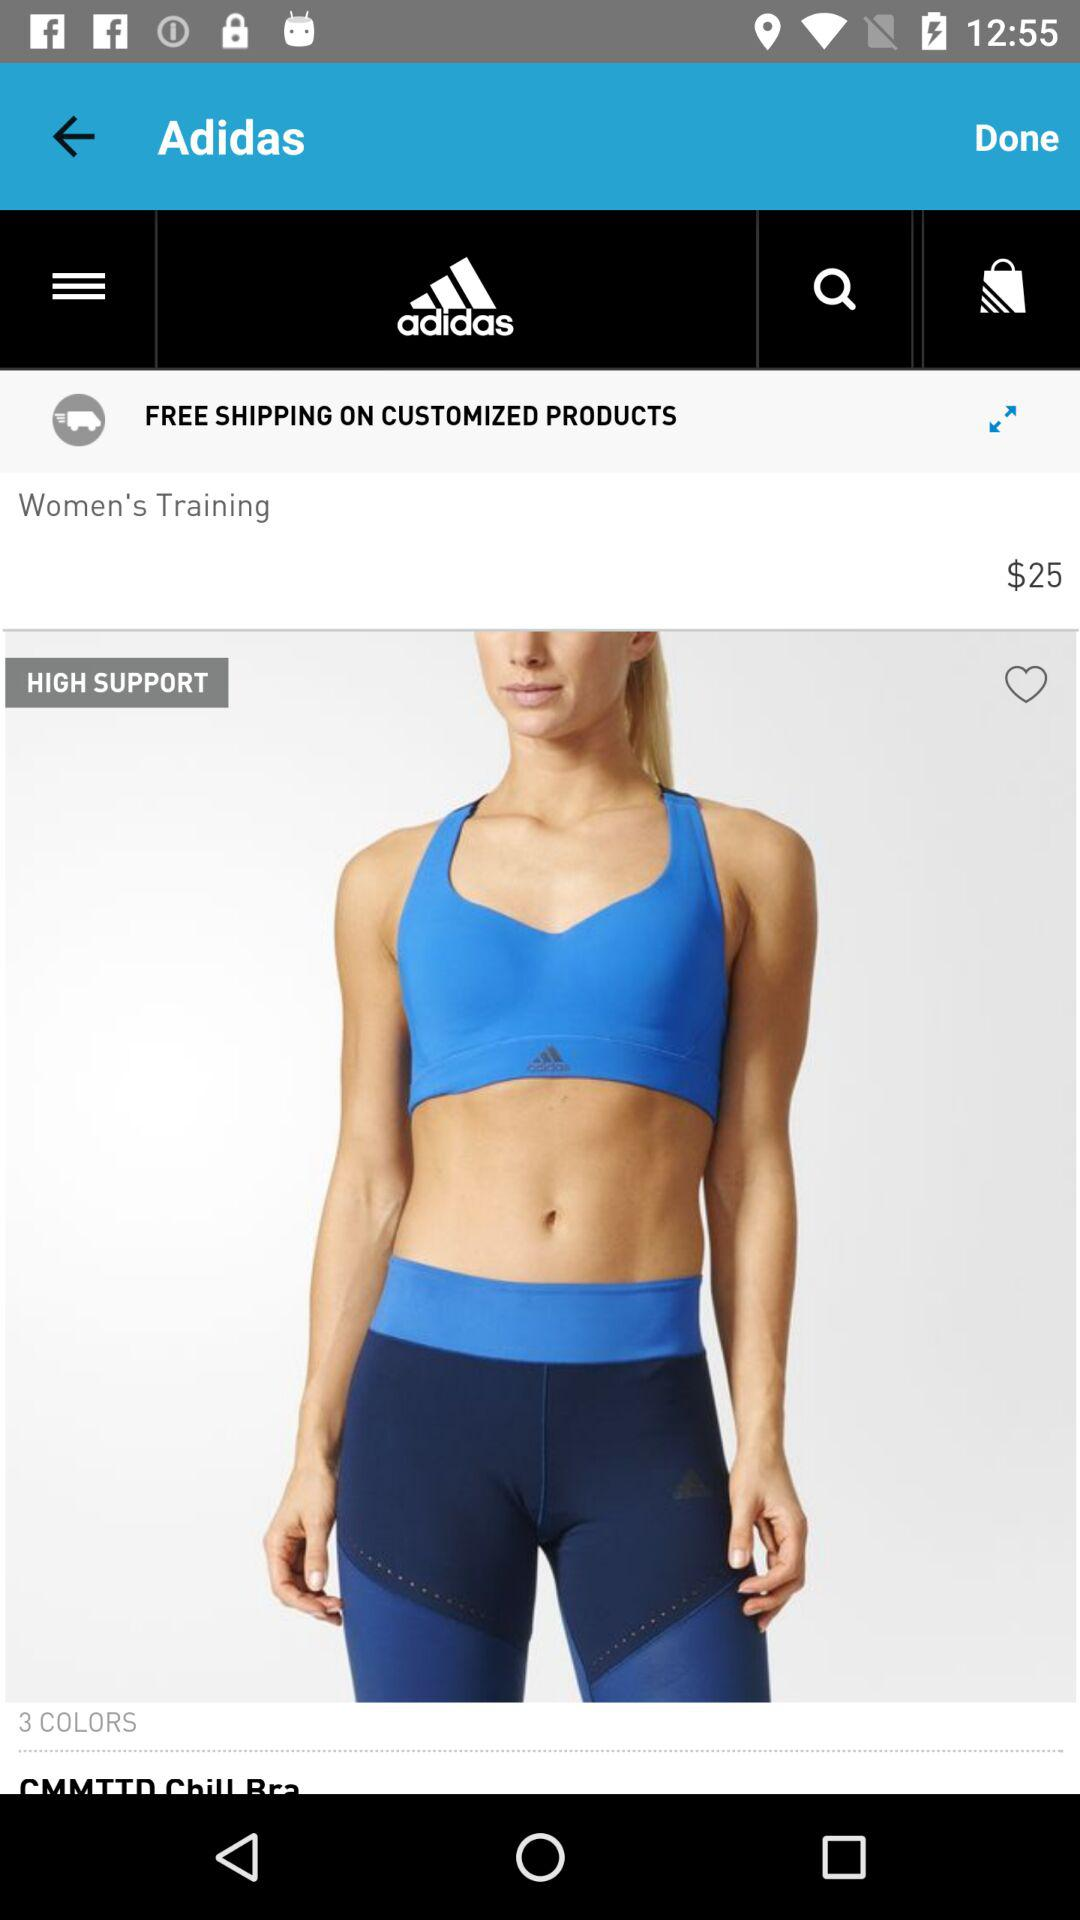How many colors of products are there? There are 3 colors. 